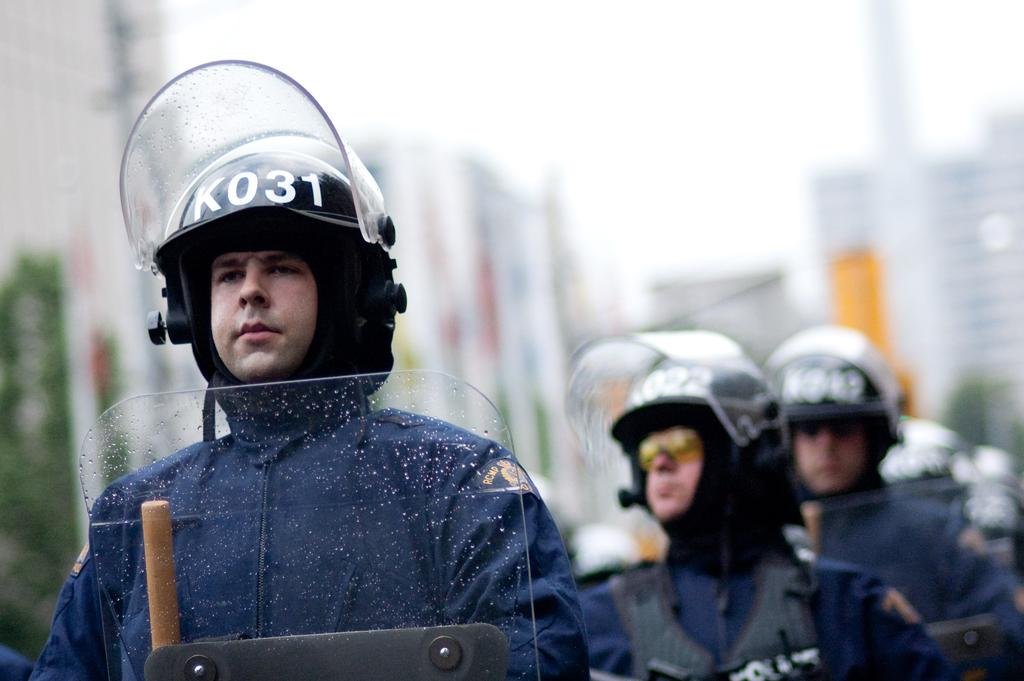What can be seen in the image? There are persons standing in the image. What are the persons wearing on their heads? The persons are wearing helmets. Can you describe the background of the image? The background of the image is blurred. What type of quiver is visible on the person's back in the image? There is no quiver visible on the person's back in the image. What type of agreement was reached by the persons in the image? There is no indication of an agreement or discussion between the persons in the image. 